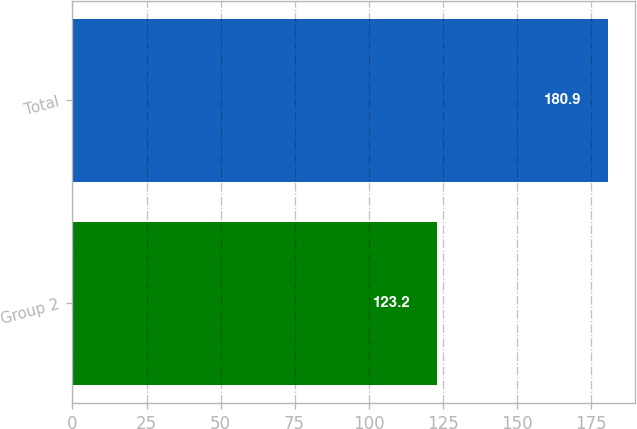<chart> <loc_0><loc_0><loc_500><loc_500><bar_chart><fcel>Group 2<fcel>Total<nl><fcel>123.2<fcel>180.9<nl></chart> 